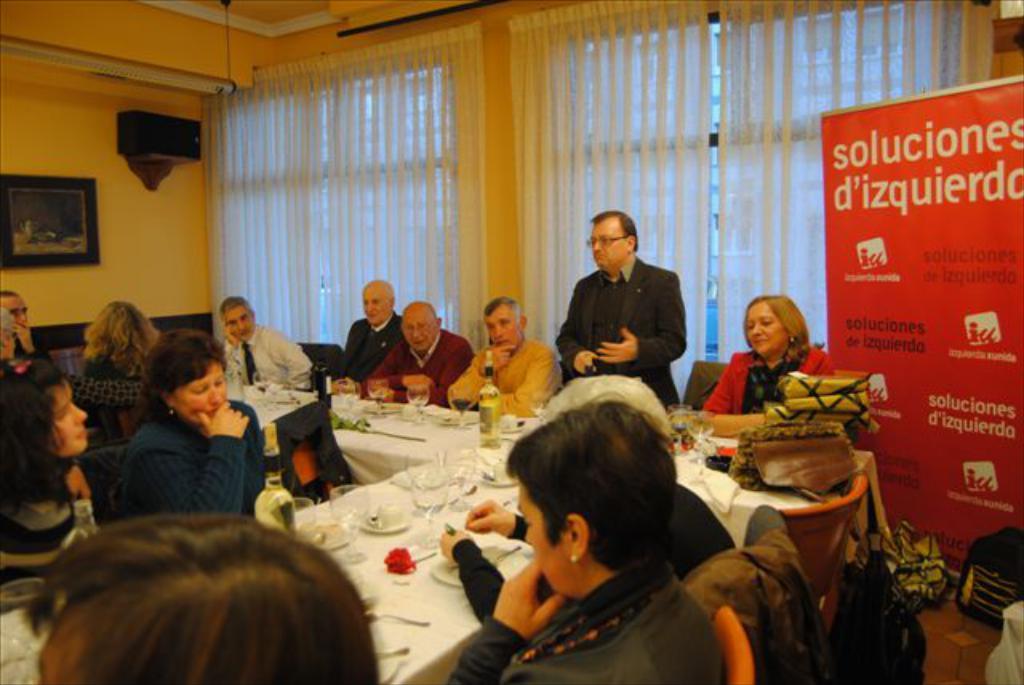Describe this image in one or two sentences. In this image I can see the group of people sitting in-front of the table and one person is standing. On the table there are plates,glasses and the bottle. To the right there is a banner. And to the left there is a frame attached to the wall. 